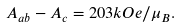<formula> <loc_0><loc_0><loc_500><loc_500>A _ { a b } - A _ { c } = 2 0 3 k O e / \mu _ { B } .</formula> 